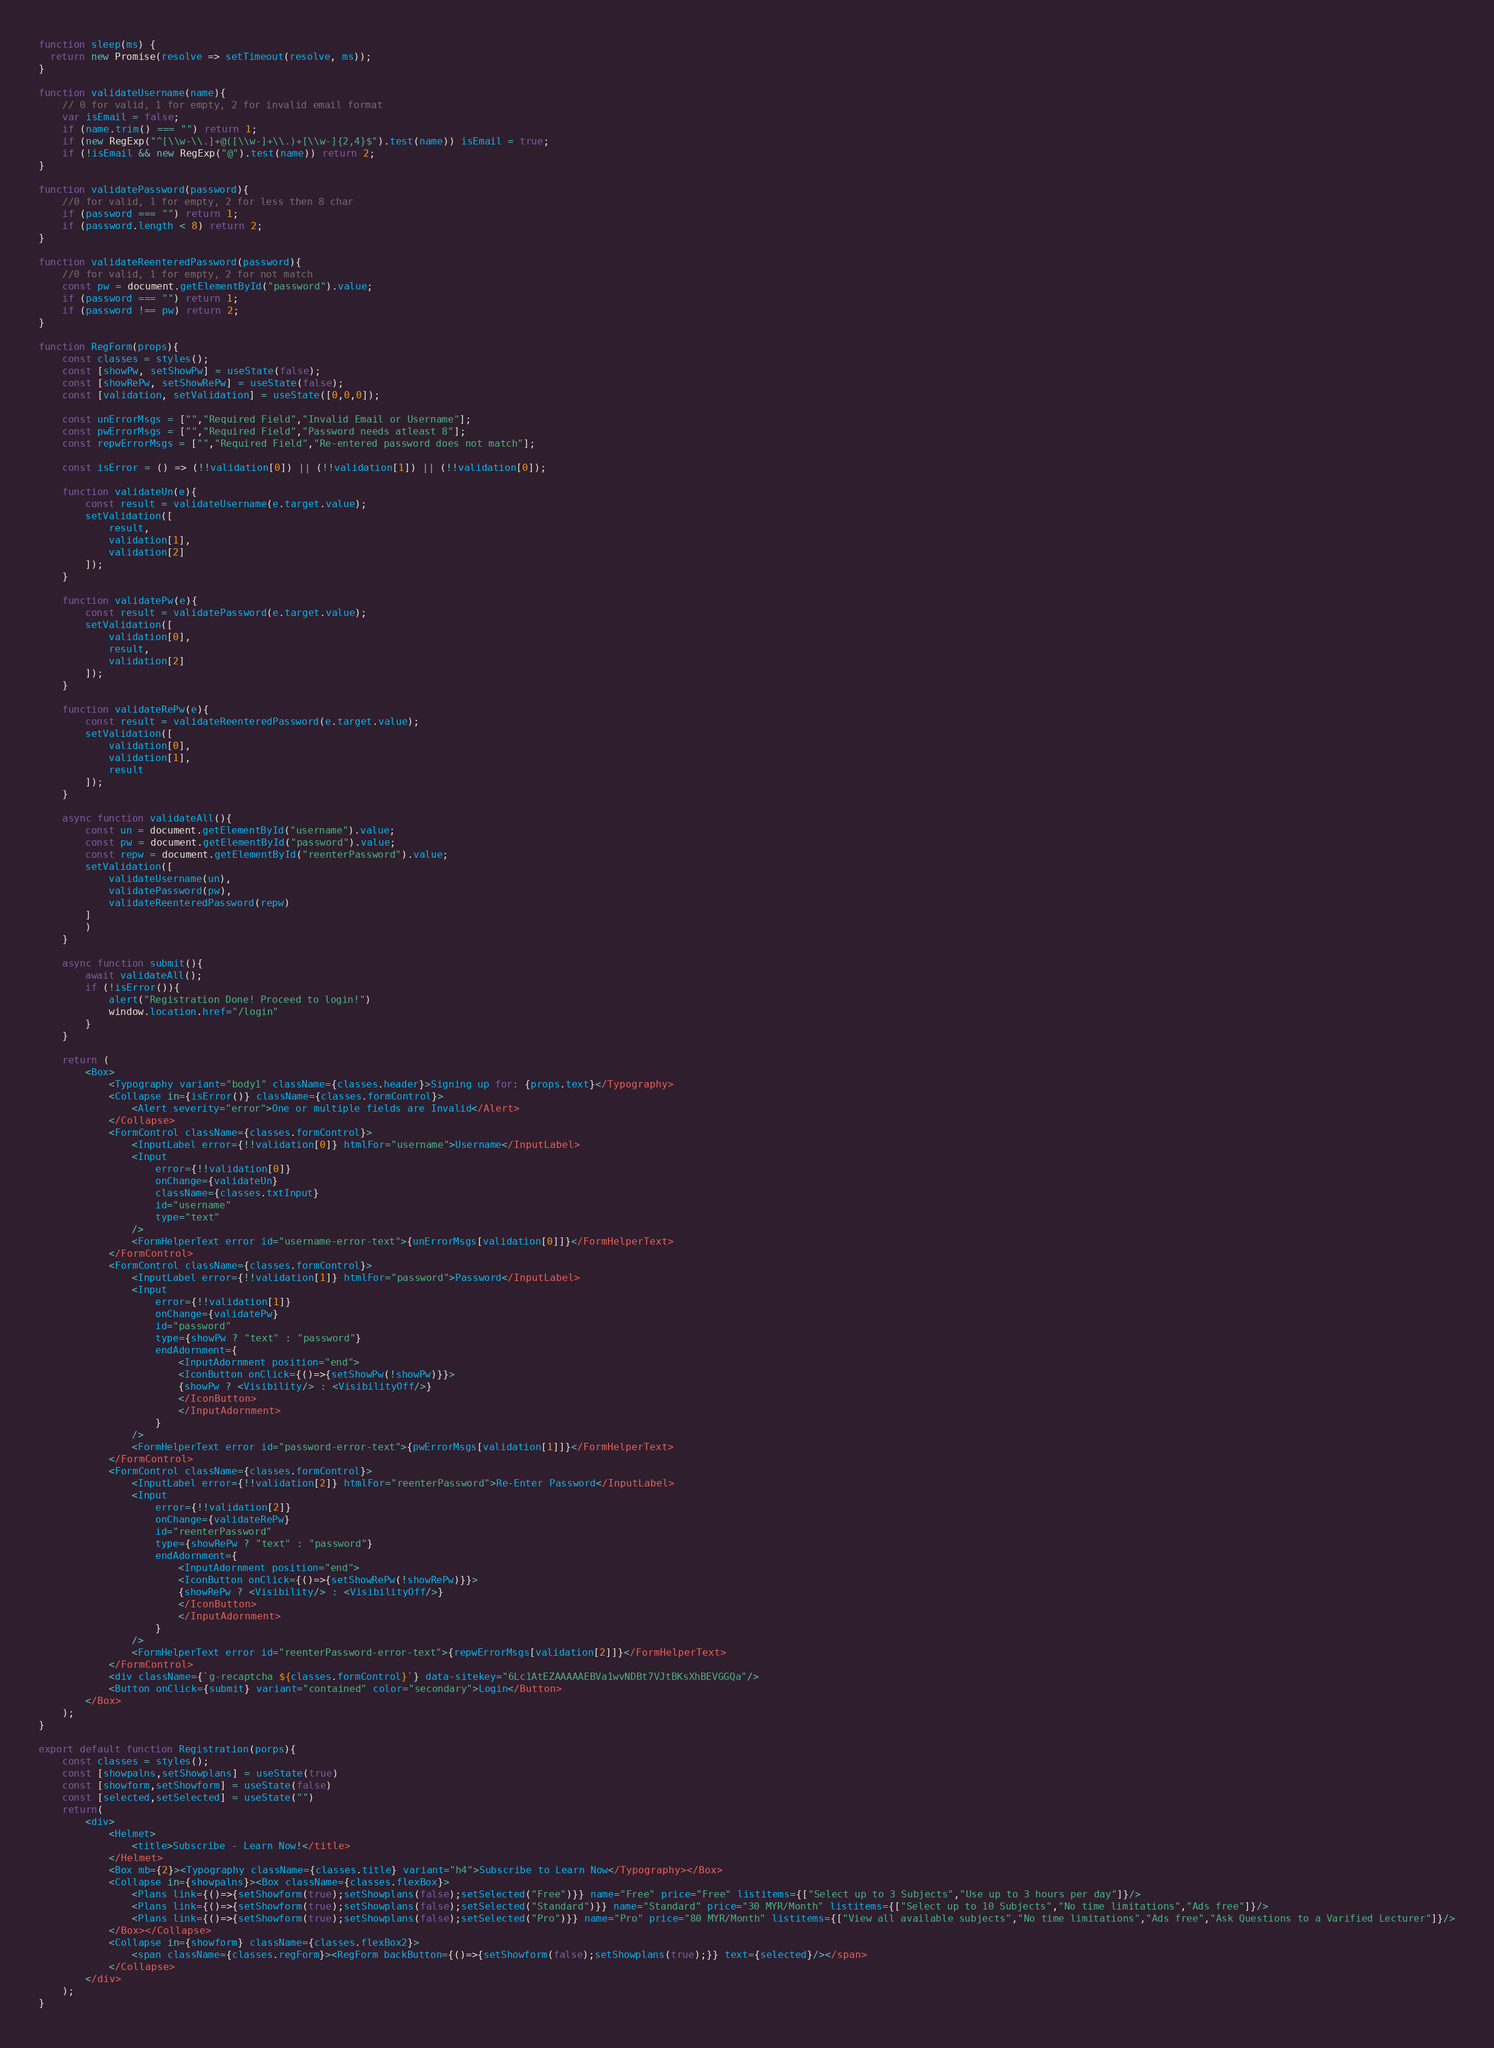Convert code to text. <code><loc_0><loc_0><loc_500><loc_500><_JavaScript_>function sleep(ms) {
  return new Promise(resolve => setTimeout(resolve, ms));
}

function validateUsername(name){
	// 0 for valid, 1 for empty, 2 for invalid email format
	var isEmail = false;
	if (name.trim() === "") return 1;
	if (new RegExp("^[\\w-\\.]+@([\\w-]+\\.)+[\\w-]{2,4}$").test(name)) isEmail = true;
	if (!isEmail && new RegExp("@").test(name)) return 2;
}

function validatePassword(password){
	//0 for valid, 1 for empty, 2 for less then 8 char
	if (password === "") return 1;
	if (password.length < 8) return 2;
}

function validateReenteredPassword(password){
	//0 for valid, 1 for empty, 2 for not match
	const pw = document.getElementById("password").value;
	if (password === "") return 1;
	if (password !== pw) return 2;
}

function RegForm(props){
	const classes = styles();
	const [showPw, setShowPw] = useState(false);
	const [showRePw, setShowRePw] = useState(false);
	const [validation, setValidation] = useState([0,0,0]);

	const unErrorMsgs = ["","Required Field","Invalid Email or Username"];
	const pwErrorMsgs = ["","Required Field","Password needs atleast 8"];
	const repwErrorMsgs = ["","Required Field","Re-entered password does not match"];

	const isError = () => (!!validation[0]) || (!!validation[1]) || (!!validation[0]);

	function validateUn(e){
		const result = validateUsername(e.target.value);
		setValidation([
			result,
			validation[1],
			validation[2]
		]); 
	}

	function validatePw(e){
		const result = validatePassword(e.target.value);
		setValidation([
			validation[0],
			result,
			validation[2]
		]); 	
	}

	function validateRePw(e){
		const result = validateReenteredPassword(e.target.value);
		setValidation([
			validation[0],
			validation[1],
			result
		]);	
	}

	async function validateAll(){
		const un = document.getElementById("username").value;
		const pw = document.getElementById("password").value;
		const repw = document.getElementById("reenterPassword").value;
		setValidation([
			validateUsername(un),
			validatePassword(pw),
			validateReenteredPassword(repw)
		]
		)
	}

	async function submit(){
		await validateAll();
		if (!isError()){
			alert("Registration Done! Proceed to login!")
			window.location.href="/login"
		}
	}

	return (
		<Box>
			<Typography variant="body1" className={classes.header}>Signing up for: {props.text}</Typography>
			<Collapse in={isError()} className={classes.formControl}>
				<Alert severity="error">One or multiple fields are Invalid</Alert>
			</Collapse>
			<FormControl className={classes.formControl}>
				<InputLabel error={!!validation[0]} htmlFor="username">Username</InputLabel>
				<Input
					error={!!validation[0]}
					onChange={validateUn}
					className={classes.txtInput}
					id="username"
					type="text"
				/>
				<FormHelperText error id="username-error-text">{unErrorMsgs[validation[0]]}</FormHelperText>
			</FormControl>
			<FormControl className={classes.formControl}>
				<InputLabel error={!!validation[1]} htmlFor="password">Password</InputLabel>
				<Input
					error={!!validation[1]}
					onChange={validatePw}
					id="password"
					type={showPw ? "text" : "password"}
					endAdornment={
						<InputAdornment position="end">
						<IconButton onClick={()=>{setShowPw(!showPw)}}>
						{showPw ? <Visibility/> : <VisibilityOff/>}
						</IconButton>
						</InputAdornment>
					}
				/>
				<FormHelperText error id="password-error-text">{pwErrorMsgs[validation[1]]}</FormHelperText>
			</FormControl>
			<FormControl className={classes.formControl}>
				<InputLabel error={!!validation[2]} htmlFor="reenterPassword">Re-Enter Password</InputLabel>
				<Input
					error={!!validation[2]}
					onChange={validateRePw}
					id="reenterPassword"
					type={showRePw ? "text" : "password"}
					endAdornment={
						<InputAdornment position="end">
						<IconButton onClick={()=>{setShowRePw(!showRePw)}}>
						{showRePw ? <Visibility/> : <VisibilityOff/>}
						</IconButton>
						</InputAdornment>
					}
				/>
				<FormHelperText error id="reenterPassword-error-text">{repwErrorMsgs[validation[2]]}</FormHelperText>
			</FormControl>
			<div className={`g-recaptcha ${classes.formControl}`} data-sitekey="6Lc1AtEZAAAAAEBVa1wvNDBt7VJtBKsXhBEVGGQa"/>
			<Button onClick={submit} variant="contained" color="secondary">Login</Button>
		</Box>
	);
}

export default function Registration(porps){
	const classes = styles();
	const [showpalns,setShowplans] = useState(true)
	const [showform,setShowform] = useState(false)
	const [selected,setSelected] = useState("")
	return(
		<div>
			<Helmet>
				<title>Subscribe - Learn Now!</title>
			</Helmet>
			<Box mb={2}><Typography className={classes.title} variant="h4">Subscribe to Learn Now</Typography></Box>
			<Collapse in={showpalns}><Box className={classes.flexBox}>
				<Plans link={()=>{setShowform(true);setShowplans(false);setSelected("Free")}} name="Free" price="Free" listitems={["Select up to 3 Subjects","Use up to 3 hours per day"]}/>
				<Plans link={()=>{setShowform(true);setShowplans(false);setSelected("Standard")}} name="Standard" price="30 MYR/Month" listitems={["Select up to 10 Subjects","No time limitations","Ads free"]}/>
				<Plans link={()=>{setShowform(true);setShowplans(false);setSelected("Pro")}} name="Pro" price="80 MYR/Month" listitems={["View all available subjects","No time limitations","Ads free","Ask Questions to a Varified Lecturer"]}/>
			</Box></Collapse>
			<Collapse in={showform} className={classes.flexBox2}>
				<span className={classes.regForm}><RegForm backButton={()=>{setShowform(false);setShowplans(true);}} text={selected}/></span>
			</Collapse>
		</div>
	);
}</code> 